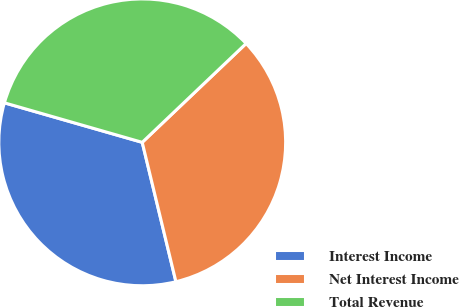Convert chart. <chart><loc_0><loc_0><loc_500><loc_500><pie_chart><fcel>Interest Income<fcel>Net Interest Income<fcel>Total Revenue<nl><fcel>33.22%<fcel>33.33%<fcel>33.45%<nl></chart> 